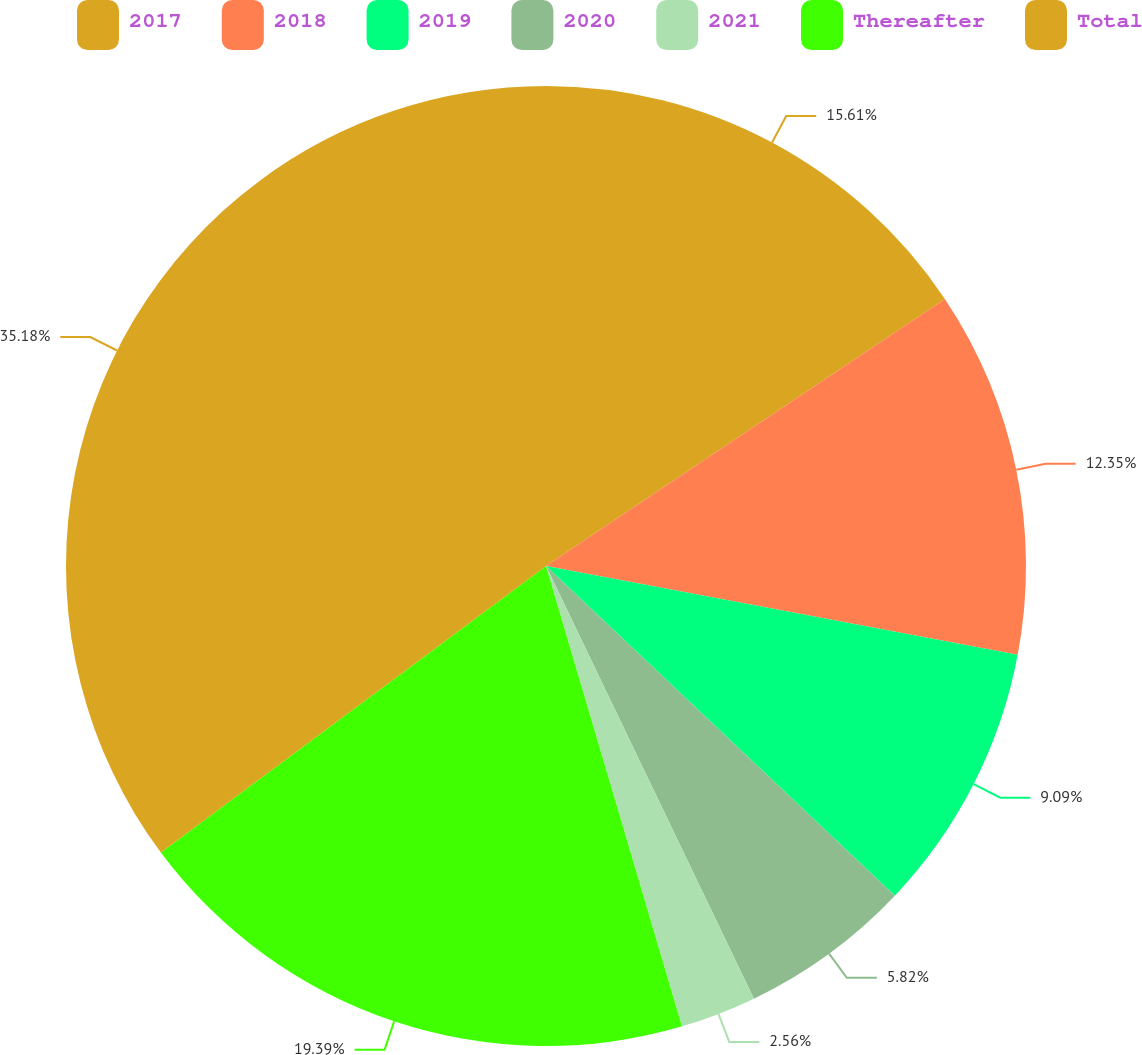Convert chart to OTSL. <chart><loc_0><loc_0><loc_500><loc_500><pie_chart><fcel>2017<fcel>2018<fcel>2019<fcel>2020<fcel>2021<fcel>Thereafter<fcel>Total<nl><fcel>15.61%<fcel>12.35%<fcel>9.09%<fcel>5.82%<fcel>2.56%<fcel>19.39%<fcel>35.18%<nl></chart> 